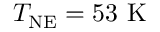<formula> <loc_0><loc_0><loc_500><loc_500>T _ { N E } = 5 3 \ K</formula> 